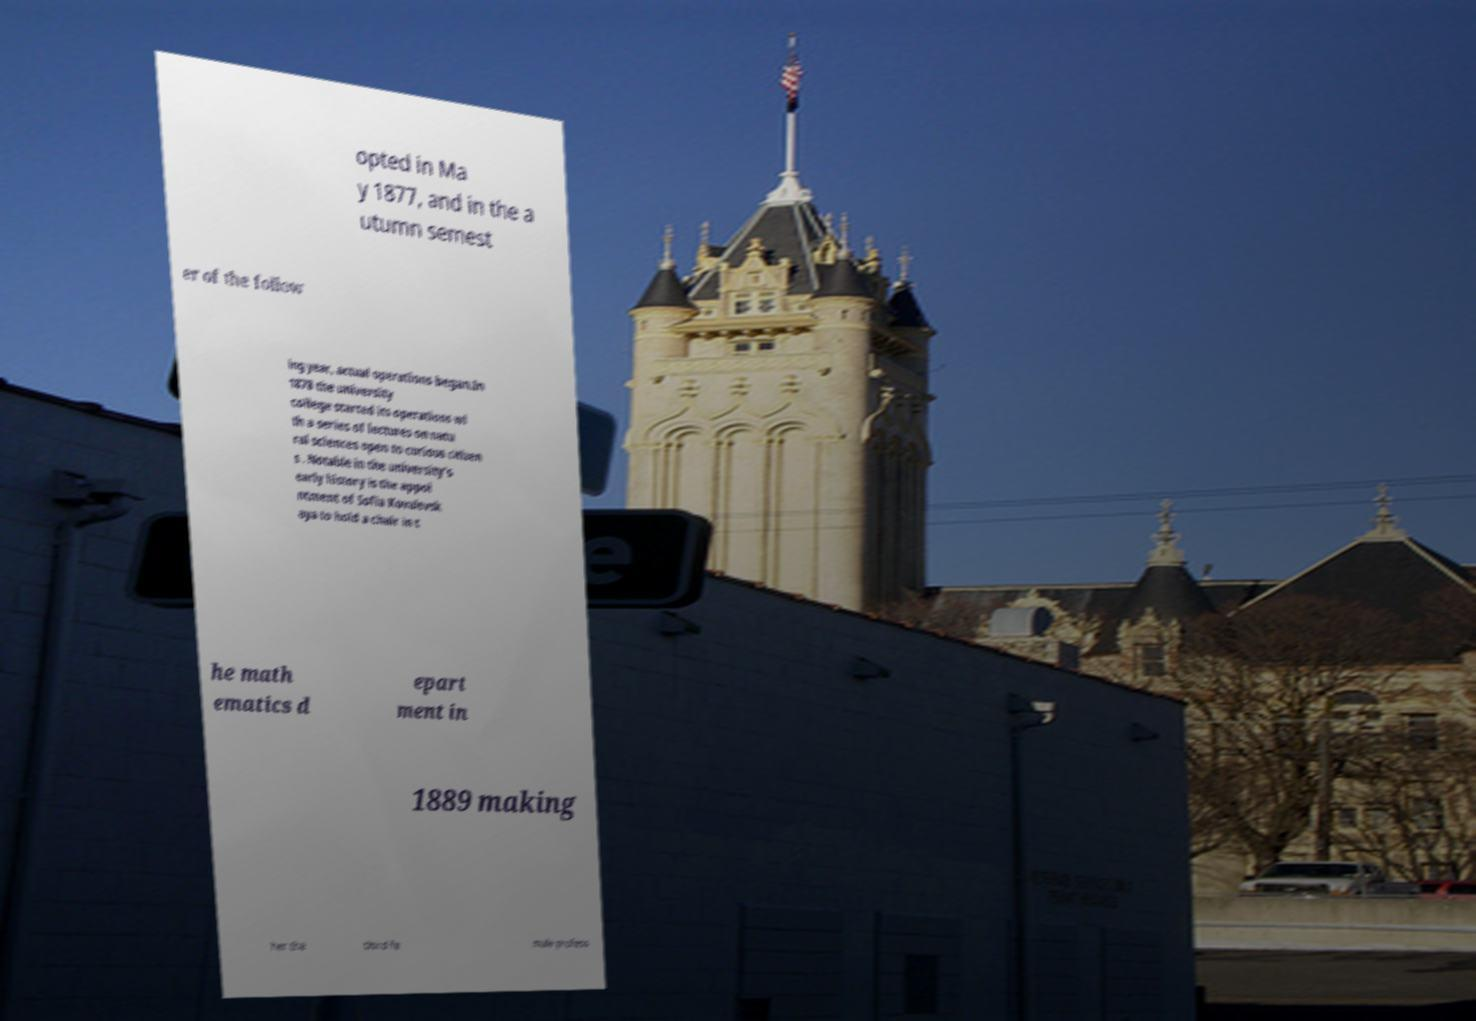For documentation purposes, I need the text within this image transcribed. Could you provide that? opted in Ma y 1877, and in the a utumn semest er of the follow ing year, actual operations began.In 1878 the university college started its operations wi th a series of lectures on natu ral sciences open to curious citizen s . Notable in the university's early history is the appoi ntment of Sofia Kovalevsk aya to hold a chair in t he math ematics d epart ment in 1889 making her the third fe male profess 